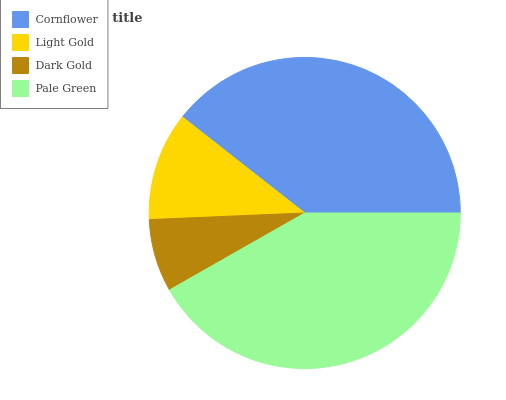Is Dark Gold the minimum?
Answer yes or no. Yes. Is Pale Green the maximum?
Answer yes or no. Yes. Is Light Gold the minimum?
Answer yes or no. No. Is Light Gold the maximum?
Answer yes or no. No. Is Cornflower greater than Light Gold?
Answer yes or no. Yes. Is Light Gold less than Cornflower?
Answer yes or no. Yes. Is Light Gold greater than Cornflower?
Answer yes or no. No. Is Cornflower less than Light Gold?
Answer yes or no. No. Is Cornflower the high median?
Answer yes or no. Yes. Is Light Gold the low median?
Answer yes or no. Yes. Is Dark Gold the high median?
Answer yes or no. No. Is Pale Green the low median?
Answer yes or no. No. 